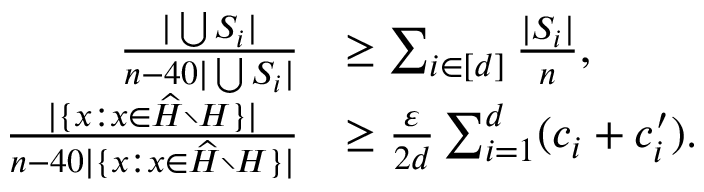<formula> <loc_0><loc_0><loc_500><loc_500>\begin{array} { r l } { \frac { | \bigcup S _ { i } | } { n - 4 0 | \bigcup S _ { i } | } } & { \geq \sum _ { i \in [ d ] } \frac { | S _ { i } | } { n } , } \\ { \frac { | \{ x \colon x \in \widehat { H } \ H \} | } { n - 4 0 | \{ x \colon x \in \widehat { H } \ H \} | } } & { \geq \frac { \varepsilon } { 2 d } \sum _ { i = 1 } ^ { d } ( c _ { i } + c _ { i } ^ { \prime } ) . } \end{array}</formula> 